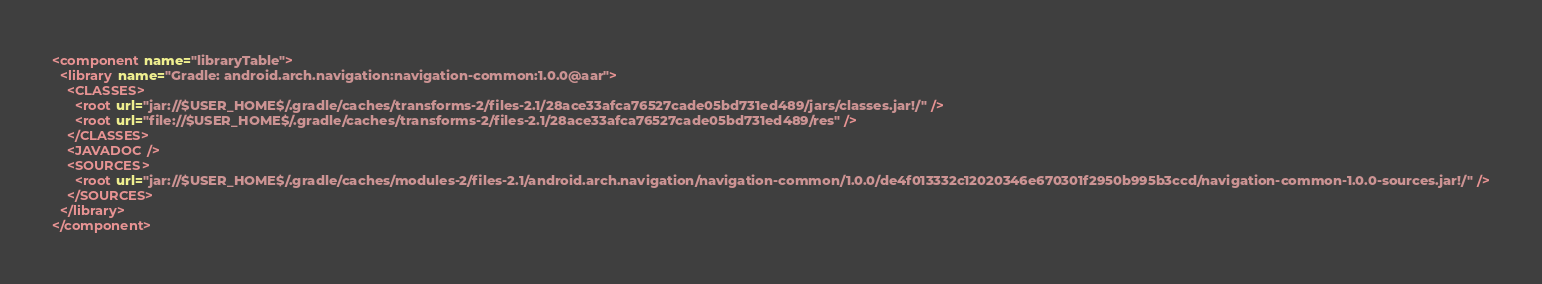Convert code to text. <code><loc_0><loc_0><loc_500><loc_500><_XML_><component name="libraryTable">
  <library name="Gradle: android.arch.navigation:navigation-common:1.0.0@aar">
    <CLASSES>
      <root url="jar://$USER_HOME$/.gradle/caches/transforms-2/files-2.1/28ace33afca76527cade05bd731ed489/jars/classes.jar!/" />
      <root url="file://$USER_HOME$/.gradle/caches/transforms-2/files-2.1/28ace33afca76527cade05bd731ed489/res" />
    </CLASSES>
    <JAVADOC />
    <SOURCES>
      <root url="jar://$USER_HOME$/.gradle/caches/modules-2/files-2.1/android.arch.navigation/navigation-common/1.0.0/de4f013332c12020346e670301f2950b995b3ccd/navigation-common-1.0.0-sources.jar!/" />
    </SOURCES>
  </library>
</component></code> 